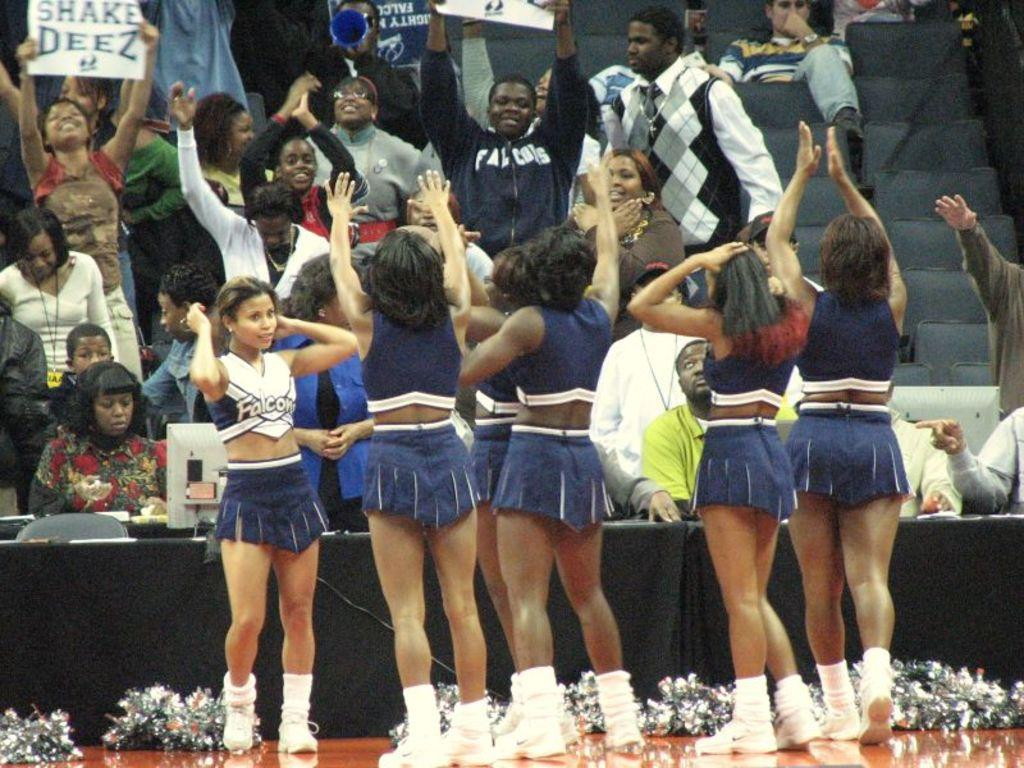<image>
Share a concise interpretation of the image provided. Cheerleaders pep up the crowd as a woman holds a sign that reads, "Shake Deez". 